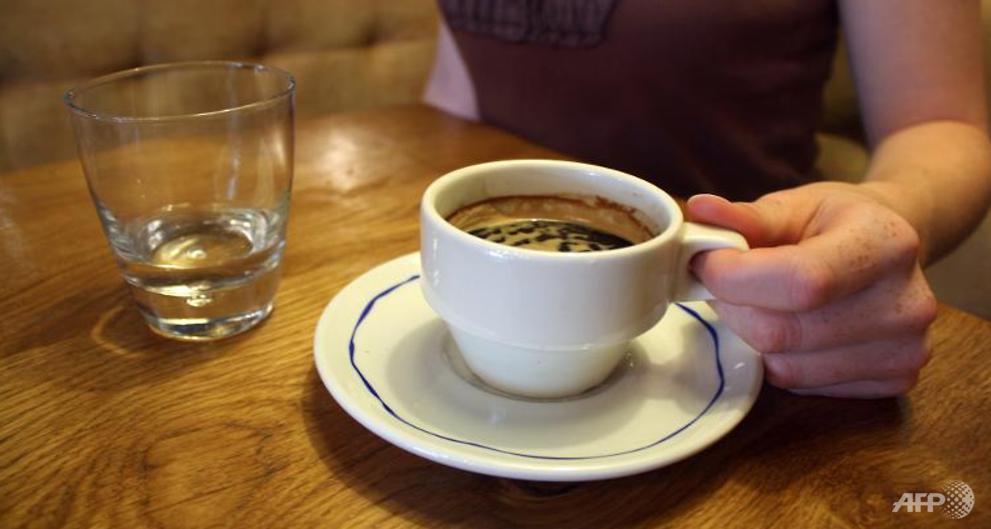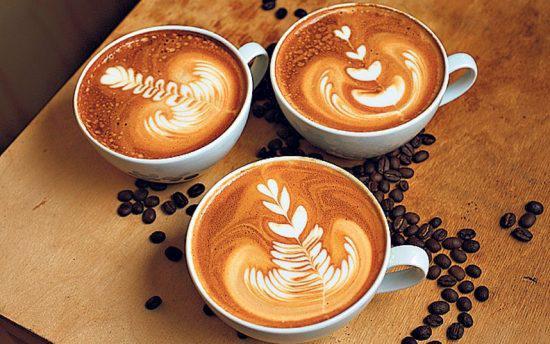The first image is the image on the left, the second image is the image on the right. Evaluate the accuracy of this statement regarding the images: "There are three or more cups with coffee in them.". Is it true? Answer yes or no. Yes. The first image is the image on the left, the second image is the image on the right. For the images displayed, is the sentence "There are no more than two cups of coffee." factually correct? Answer yes or no. No. 